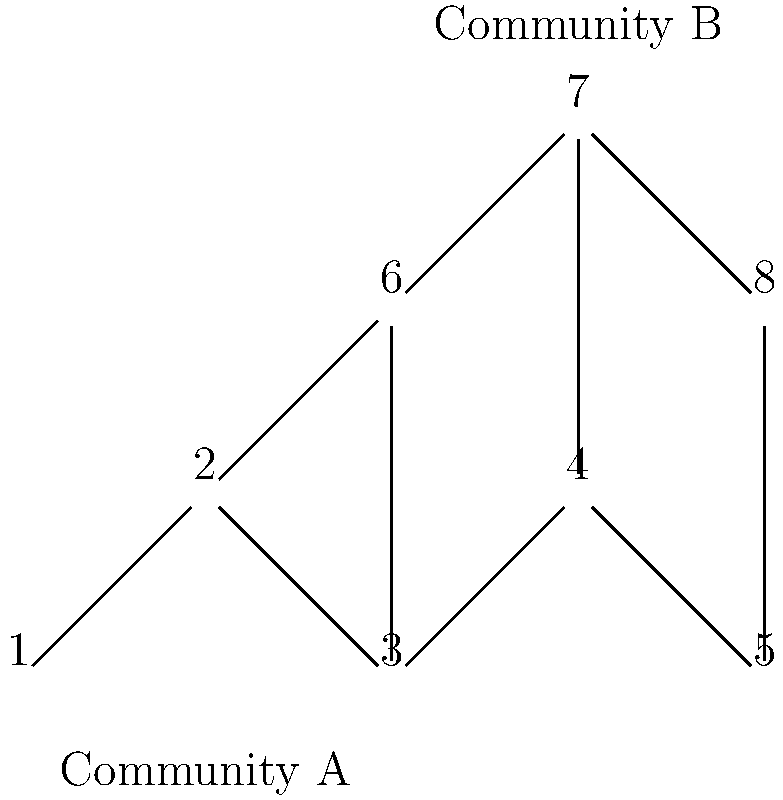As a film distributor, you're planning the marketing strategy for a new sci-fi movie. The graph represents social media connections between potential audience members, with two distinct communities detected. Community A (nodes 1-5) represents sci-fi enthusiasts, while Community B (nodes 6-8) represents general movie-goers. If your budget allows for targeted marketing to reach 60% of one community, which community should you choose to maximize potential box office revenue, and what is the optimal number of individuals to target? To solve this problem, we need to follow these steps:

1. Identify the size of each community:
   Community A: 5 nodes (1, 2, 3, 4, 5)
   Community B: 3 nodes (6, 7, 8)

2. Calculate 60% of each community:
   Community A: $60\% \times 5 = 3$ individuals
   Community B: $60\% \times 3 = 1.8$ individuals (round up to 2)

3. Consider the characteristics of each community:
   Community A: Sci-fi enthusiasts (more likely to be interested in the movie)
   Community B: General movie-goers (less specific interest)

4. Analyze the potential impact:
   Targeting Community A:
   - Reaches 3 sci-fi enthusiasts
   - Higher likelihood of word-of-mouth promotion within the community
   - Potential to influence the 2 non-targeted members of Community A

   Targeting Community B:
   - Reaches 2 general movie-goers
   - Less specific interest in the sci-fi genre
   - Smaller community size limits potential word-of-mouth impact

5. Make a decision:
   Choose Community A because:
   - It targets more individuals (3 vs. 2)
   - The targeted individuals are more likely to be interested in a sci-fi movie
   - There's a higher potential for word-of-mouth promotion within a larger, more interested community

Therefore, the optimal strategy is to target Community A, reaching 3 individuals (60% of 5) to maximize potential box office revenue.
Answer: Target Community A, reaching 3 individuals. 